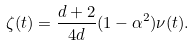Convert formula to latex. <formula><loc_0><loc_0><loc_500><loc_500>\zeta ( t ) = \frac { d + 2 } { 4 d } ( 1 - \alpha ^ { 2 } ) \nu ( t ) .</formula> 